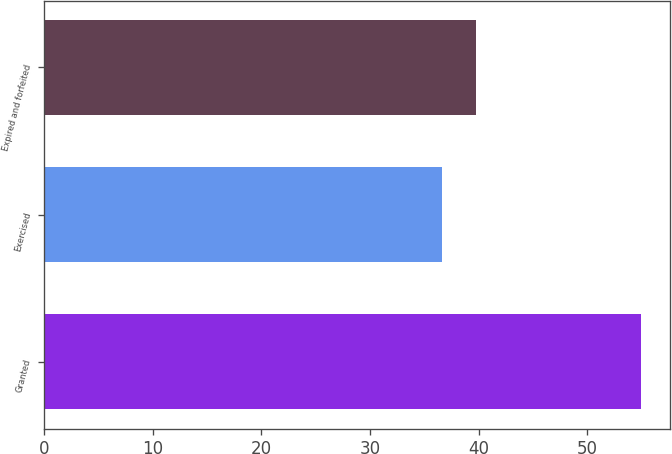<chart> <loc_0><loc_0><loc_500><loc_500><bar_chart><fcel>Granted<fcel>Exercised<fcel>Expired and forfeited<nl><fcel>54.91<fcel>36.66<fcel>39.73<nl></chart> 